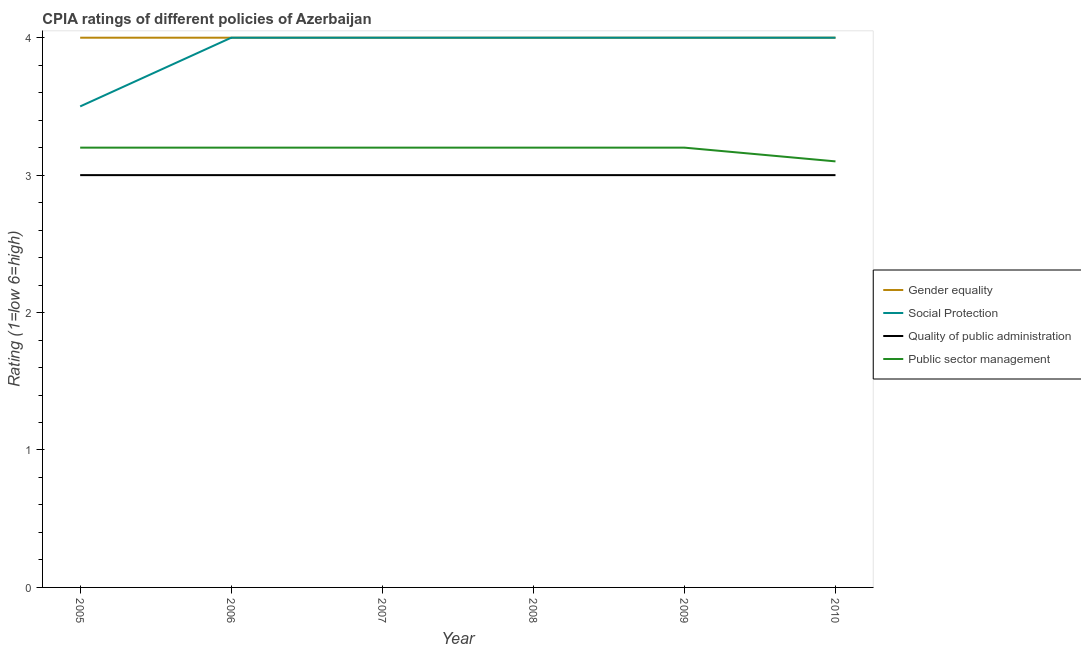How many different coloured lines are there?
Offer a terse response. 4. Does the line corresponding to cpia rating of quality of public administration intersect with the line corresponding to cpia rating of public sector management?
Your answer should be very brief. No. Is the number of lines equal to the number of legend labels?
Offer a terse response. Yes. What is the cpia rating of social protection in 2006?
Your answer should be very brief. 4. Across all years, what is the maximum cpia rating of quality of public administration?
Provide a short and direct response. 3. Across all years, what is the minimum cpia rating of gender equality?
Offer a terse response. 4. What is the difference between the cpia rating of social protection in 2007 and that in 2010?
Your answer should be very brief. 0. What is the difference between the cpia rating of quality of public administration in 2008 and the cpia rating of gender equality in 2010?
Offer a very short reply. -1. What is the average cpia rating of social protection per year?
Your response must be concise. 3.92. In the year 2010, what is the difference between the cpia rating of gender equality and cpia rating of quality of public administration?
Provide a succinct answer. 1. What is the ratio of the cpia rating of public sector management in 2006 to that in 2007?
Make the answer very short. 1. Is the cpia rating of gender equality in 2008 less than that in 2009?
Give a very brief answer. No. Is the difference between the cpia rating of public sector management in 2006 and 2010 greater than the difference between the cpia rating of social protection in 2006 and 2010?
Offer a very short reply. Yes. What is the difference between the highest and the second highest cpia rating of public sector management?
Your response must be concise. 0. Is the sum of the cpia rating of social protection in 2007 and 2008 greater than the maximum cpia rating of quality of public administration across all years?
Give a very brief answer. Yes. Does the cpia rating of quality of public administration monotonically increase over the years?
Offer a terse response. No. How many lines are there?
Keep it short and to the point. 4. How many years are there in the graph?
Provide a succinct answer. 6. What is the difference between two consecutive major ticks on the Y-axis?
Offer a terse response. 1. Does the graph contain grids?
Offer a terse response. No. Where does the legend appear in the graph?
Your response must be concise. Center right. How are the legend labels stacked?
Offer a terse response. Vertical. What is the title of the graph?
Your answer should be very brief. CPIA ratings of different policies of Azerbaijan. What is the Rating (1=low 6=high) in Gender equality in 2005?
Your response must be concise. 4. What is the Rating (1=low 6=high) of Quality of public administration in 2005?
Offer a very short reply. 3. What is the Rating (1=low 6=high) in Social Protection in 2006?
Give a very brief answer. 4. What is the Rating (1=low 6=high) of Gender equality in 2007?
Offer a terse response. 4. What is the Rating (1=low 6=high) of Gender equality in 2008?
Make the answer very short. 4. What is the Rating (1=low 6=high) in Social Protection in 2008?
Your answer should be compact. 4. What is the Rating (1=low 6=high) of Social Protection in 2009?
Offer a terse response. 4. What is the Rating (1=low 6=high) of Public sector management in 2009?
Provide a succinct answer. 3.2. What is the Rating (1=low 6=high) in Gender equality in 2010?
Your answer should be compact. 4. What is the Rating (1=low 6=high) of Public sector management in 2010?
Provide a short and direct response. 3.1. Across all years, what is the maximum Rating (1=low 6=high) in Social Protection?
Provide a short and direct response. 4. Across all years, what is the maximum Rating (1=low 6=high) in Public sector management?
Your response must be concise. 3.2. What is the total Rating (1=low 6=high) in Quality of public administration in the graph?
Your answer should be very brief. 18. What is the total Rating (1=low 6=high) in Public sector management in the graph?
Make the answer very short. 19.1. What is the difference between the Rating (1=low 6=high) in Public sector management in 2005 and that in 2006?
Your response must be concise. 0. What is the difference between the Rating (1=low 6=high) in Gender equality in 2005 and that in 2007?
Make the answer very short. 0. What is the difference between the Rating (1=low 6=high) of Social Protection in 2005 and that in 2007?
Offer a terse response. -0.5. What is the difference between the Rating (1=low 6=high) in Social Protection in 2005 and that in 2008?
Provide a short and direct response. -0.5. What is the difference between the Rating (1=low 6=high) in Public sector management in 2005 and that in 2008?
Your answer should be very brief. 0. What is the difference between the Rating (1=low 6=high) in Social Protection in 2005 and that in 2010?
Ensure brevity in your answer.  -0.5. What is the difference between the Rating (1=low 6=high) in Gender equality in 2006 and that in 2007?
Offer a very short reply. 0. What is the difference between the Rating (1=low 6=high) of Quality of public administration in 2006 and that in 2007?
Make the answer very short. 0. What is the difference between the Rating (1=low 6=high) of Public sector management in 2006 and that in 2007?
Provide a short and direct response. 0. What is the difference between the Rating (1=low 6=high) of Gender equality in 2006 and that in 2008?
Provide a succinct answer. 0. What is the difference between the Rating (1=low 6=high) in Public sector management in 2006 and that in 2008?
Your response must be concise. 0. What is the difference between the Rating (1=low 6=high) in Social Protection in 2006 and that in 2009?
Offer a terse response. 0. What is the difference between the Rating (1=low 6=high) of Quality of public administration in 2006 and that in 2009?
Your answer should be compact. 0. What is the difference between the Rating (1=low 6=high) of Public sector management in 2006 and that in 2009?
Provide a short and direct response. 0. What is the difference between the Rating (1=low 6=high) of Social Protection in 2006 and that in 2010?
Provide a succinct answer. 0. What is the difference between the Rating (1=low 6=high) in Quality of public administration in 2007 and that in 2008?
Keep it short and to the point. 0. What is the difference between the Rating (1=low 6=high) in Social Protection in 2007 and that in 2009?
Your answer should be compact. 0. What is the difference between the Rating (1=low 6=high) of Public sector management in 2007 and that in 2009?
Ensure brevity in your answer.  0. What is the difference between the Rating (1=low 6=high) of Social Protection in 2007 and that in 2010?
Ensure brevity in your answer.  0. What is the difference between the Rating (1=low 6=high) of Public sector management in 2008 and that in 2009?
Offer a terse response. 0. What is the difference between the Rating (1=low 6=high) of Social Protection in 2008 and that in 2010?
Provide a succinct answer. 0. What is the difference between the Rating (1=low 6=high) in Quality of public administration in 2008 and that in 2010?
Your response must be concise. 0. What is the difference between the Rating (1=low 6=high) of Public sector management in 2008 and that in 2010?
Provide a short and direct response. 0.1. What is the difference between the Rating (1=low 6=high) of Social Protection in 2009 and that in 2010?
Offer a terse response. 0. What is the difference between the Rating (1=low 6=high) in Quality of public administration in 2009 and that in 2010?
Offer a terse response. 0. What is the difference between the Rating (1=low 6=high) in Public sector management in 2009 and that in 2010?
Offer a very short reply. 0.1. What is the difference between the Rating (1=low 6=high) in Gender equality in 2005 and the Rating (1=low 6=high) in Social Protection in 2006?
Your answer should be compact. 0. What is the difference between the Rating (1=low 6=high) in Gender equality in 2005 and the Rating (1=low 6=high) in Public sector management in 2006?
Provide a succinct answer. 0.8. What is the difference between the Rating (1=low 6=high) in Quality of public administration in 2005 and the Rating (1=low 6=high) in Public sector management in 2006?
Provide a short and direct response. -0.2. What is the difference between the Rating (1=low 6=high) in Gender equality in 2005 and the Rating (1=low 6=high) in Quality of public administration in 2007?
Keep it short and to the point. 1. What is the difference between the Rating (1=low 6=high) of Social Protection in 2005 and the Rating (1=low 6=high) of Quality of public administration in 2007?
Provide a succinct answer. 0.5. What is the difference between the Rating (1=low 6=high) of Gender equality in 2005 and the Rating (1=low 6=high) of Public sector management in 2008?
Make the answer very short. 0.8. What is the difference between the Rating (1=low 6=high) in Social Protection in 2005 and the Rating (1=low 6=high) in Quality of public administration in 2008?
Ensure brevity in your answer.  0.5. What is the difference between the Rating (1=low 6=high) of Social Protection in 2005 and the Rating (1=low 6=high) of Public sector management in 2008?
Give a very brief answer. 0.3. What is the difference between the Rating (1=low 6=high) in Quality of public administration in 2005 and the Rating (1=low 6=high) in Public sector management in 2008?
Offer a very short reply. -0.2. What is the difference between the Rating (1=low 6=high) in Gender equality in 2005 and the Rating (1=low 6=high) in Social Protection in 2009?
Offer a terse response. 0. What is the difference between the Rating (1=low 6=high) in Gender equality in 2005 and the Rating (1=low 6=high) in Quality of public administration in 2009?
Your answer should be compact. 1. What is the difference between the Rating (1=low 6=high) in Social Protection in 2005 and the Rating (1=low 6=high) in Quality of public administration in 2009?
Provide a short and direct response. 0.5. What is the difference between the Rating (1=low 6=high) of Quality of public administration in 2005 and the Rating (1=low 6=high) of Public sector management in 2009?
Your answer should be very brief. -0.2. What is the difference between the Rating (1=low 6=high) in Social Protection in 2005 and the Rating (1=low 6=high) in Public sector management in 2010?
Your response must be concise. 0.4. What is the difference between the Rating (1=low 6=high) of Gender equality in 2006 and the Rating (1=low 6=high) of Quality of public administration in 2007?
Your answer should be compact. 1. What is the difference between the Rating (1=low 6=high) of Quality of public administration in 2006 and the Rating (1=low 6=high) of Public sector management in 2007?
Your answer should be very brief. -0.2. What is the difference between the Rating (1=low 6=high) in Gender equality in 2006 and the Rating (1=low 6=high) in Quality of public administration in 2008?
Make the answer very short. 1. What is the difference between the Rating (1=low 6=high) in Social Protection in 2006 and the Rating (1=low 6=high) in Quality of public administration in 2008?
Your answer should be compact. 1. What is the difference between the Rating (1=low 6=high) of Social Protection in 2006 and the Rating (1=low 6=high) of Public sector management in 2008?
Give a very brief answer. 0.8. What is the difference between the Rating (1=low 6=high) in Gender equality in 2006 and the Rating (1=low 6=high) in Social Protection in 2009?
Your answer should be compact. 0. What is the difference between the Rating (1=low 6=high) in Gender equality in 2006 and the Rating (1=low 6=high) in Quality of public administration in 2009?
Give a very brief answer. 1. What is the difference between the Rating (1=low 6=high) in Social Protection in 2006 and the Rating (1=low 6=high) in Quality of public administration in 2009?
Offer a very short reply. 1. What is the difference between the Rating (1=low 6=high) of Social Protection in 2006 and the Rating (1=low 6=high) of Public sector management in 2009?
Give a very brief answer. 0.8. What is the difference between the Rating (1=low 6=high) of Gender equality in 2006 and the Rating (1=low 6=high) of Social Protection in 2010?
Offer a very short reply. 0. What is the difference between the Rating (1=low 6=high) in Gender equality in 2006 and the Rating (1=low 6=high) in Quality of public administration in 2010?
Provide a short and direct response. 1. What is the difference between the Rating (1=low 6=high) of Gender equality in 2006 and the Rating (1=low 6=high) of Public sector management in 2010?
Provide a succinct answer. 0.9. What is the difference between the Rating (1=low 6=high) of Social Protection in 2006 and the Rating (1=low 6=high) of Quality of public administration in 2010?
Keep it short and to the point. 1. What is the difference between the Rating (1=low 6=high) of Gender equality in 2007 and the Rating (1=low 6=high) of Quality of public administration in 2008?
Keep it short and to the point. 1. What is the difference between the Rating (1=low 6=high) of Gender equality in 2007 and the Rating (1=low 6=high) of Public sector management in 2008?
Your answer should be very brief. 0.8. What is the difference between the Rating (1=low 6=high) of Social Protection in 2007 and the Rating (1=low 6=high) of Quality of public administration in 2008?
Offer a terse response. 1. What is the difference between the Rating (1=low 6=high) in Social Protection in 2007 and the Rating (1=low 6=high) in Public sector management in 2008?
Offer a terse response. 0.8. What is the difference between the Rating (1=low 6=high) in Gender equality in 2007 and the Rating (1=low 6=high) in Social Protection in 2009?
Offer a terse response. 0. What is the difference between the Rating (1=low 6=high) in Gender equality in 2007 and the Rating (1=low 6=high) in Public sector management in 2009?
Your response must be concise. 0.8. What is the difference between the Rating (1=low 6=high) of Social Protection in 2007 and the Rating (1=low 6=high) of Quality of public administration in 2009?
Your answer should be compact. 1. What is the difference between the Rating (1=low 6=high) of Quality of public administration in 2007 and the Rating (1=low 6=high) of Public sector management in 2009?
Your answer should be very brief. -0.2. What is the difference between the Rating (1=low 6=high) in Gender equality in 2007 and the Rating (1=low 6=high) in Social Protection in 2010?
Provide a succinct answer. 0. What is the difference between the Rating (1=low 6=high) in Social Protection in 2007 and the Rating (1=low 6=high) in Quality of public administration in 2010?
Make the answer very short. 1. What is the difference between the Rating (1=low 6=high) of Quality of public administration in 2007 and the Rating (1=low 6=high) of Public sector management in 2010?
Provide a succinct answer. -0.1. What is the difference between the Rating (1=low 6=high) in Gender equality in 2008 and the Rating (1=low 6=high) in Social Protection in 2009?
Provide a short and direct response. 0. What is the difference between the Rating (1=low 6=high) of Gender equality in 2008 and the Rating (1=low 6=high) of Quality of public administration in 2009?
Your response must be concise. 1. What is the difference between the Rating (1=low 6=high) of Gender equality in 2008 and the Rating (1=low 6=high) of Public sector management in 2009?
Your answer should be very brief. 0.8. What is the difference between the Rating (1=low 6=high) of Social Protection in 2008 and the Rating (1=low 6=high) of Quality of public administration in 2009?
Your answer should be very brief. 1. What is the difference between the Rating (1=low 6=high) of Social Protection in 2008 and the Rating (1=low 6=high) of Public sector management in 2009?
Your response must be concise. 0.8. What is the difference between the Rating (1=low 6=high) in Gender equality in 2008 and the Rating (1=low 6=high) in Quality of public administration in 2010?
Your answer should be compact. 1. What is the difference between the Rating (1=low 6=high) of Gender equality in 2008 and the Rating (1=low 6=high) of Public sector management in 2010?
Keep it short and to the point. 0.9. What is the difference between the Rating (1=low 6=high) in Quality of public administration in 2008 and the Rating (1=low 6=high) in Public sector management in 2010?
Keep it short and to the point. -0.1. What is the difference between the Rating (1=low 6=high) of Gender equality in 2009 and the Rating (1=low 6=high) of Quality of public administration in 2010?
Your answer should be compact. 1. What is the difference between the Rating (1=low 6=high) in Gender equality in 2009 and the Rating (1=low 6=high) in Public sector management in 2010?
Offer a terse response. 0.9. What is the average Rating (1=low 6=high) of Social Protection per year?
Ensure brevity in your answer.  3.92. What is the average Rating (1=low 6=high) of Quality of public administration per year?
Provide a succinct answer. 3. What is the average Rating (1=low 6=high) of Public sector management per year?
Offer a very short reply. 3.18. In the year 2005, what is the difference between the Rating (1=low 6=high) in Gender equality and Rating (1=low 6=high) in Social Protection?
Offer a very short reply. 0.5. In the year 2005, what is the difference between the Rating (1=low 6=high) in Gender equality and Rating (1=low 6=high) in Quality of public administration?
Ensure brevity in your answer.  1. In the year 2005, what is the difference between the Rating (1=low 6=high) in Social Protection and Rating (1=low 6=high) in Quality of public administration?
Make the answer very short. 0.5. In the year 2005, what is the difference between the Rating (1=low 6=high) of Social Protection and Rating (1=low 6=high) of Public sector management?
Give a very brief answer. 0.3. In the year 2006, what is the difference between the Rating (1=low 6=high) of Gender equality and Rating (1=low 6=high) of Social Protection?
Ensure brevity in your answer.  0. In the year 2006, what is the difference between the Rating (1=low 6=high) of Gender equality and Rating (1=low 6=high) of Quality of public administration?
Give a very brief answer. 1. In the year 2006, what is the difference between the Rating (1=low 6=high) of Social Protection and Rating (1=low 6=high) of Quality of public administration?
Offer a terse response. 1. In the year 2007, what is the difference between the Rating (1=low 6=high) in Gender equality and Rating (1=low 6=high) in Quality of public administration?
Offer a terse response. 1. In the year 2007, what is the difference between the Rating (1=low 6=high) of Gender equality and Rating (1=low 6=high) of Public sector management?
Your response must be concise. 0.8. In the year 2008, what is the difference between the Rating (1=low 6=high) in Gender equality and Rating (1=low 6=high) in Social Protection?
Offer a terse response. 0. In the year 2008, what is the difference between the Rating (1=low 6=high) of Quality of public administration and Rating (1=low 6=high) of Public sector management?
Keep it short and to the point. -0.2. In the year 2009, what is the difference between the Rating (1=low 6=high) of Gender equality and Rating (1=low 6=high) of Social Protection?
Your answer should be very brief. 0. In the year 2009, what is the difference between the Rating (1=low 6=high) of Gender equality and Rating (1=low 6=high) of Quality of public administration?
Provide a succinct answer. 1. In the year 2010, what is the difference between the Rating (1=low 6=high) of Social Protection and Rating (1=low 6=high) of Public sector management?
Provide a short and direct response. 0.9. In the year 2010, what is the difference between the Rating (1=low 6=high) of Quality of public administration and Rating (1=low 6=high) of Public sector management?
Provide a short and direct response. -0.1. What is the ratio of the Rating (1=low 6=high) in Gender equality in 2005 to that in 2006?
Keep it short and to the point. 1. What is the ratio of the Rating (1=low 6=high) in Gender equality in 2005 to that in 2007?
Make the answer very short. 1. What is the ratio of the Rating (1=low 6=high) of Public sector management in 2005 to that in 2007?
Offer a terse response. 1. What is the ratio of the Rating (1=low 6=high) in Quality of public administration in 2005 to that in 2008?
Your answer should be compact. 1. What is the ratio of the Rating (1=low 6=high) in Public sector management in 2005 to that in 2008?
Provide a short and direct response. 1. What is the ratio of the Rating (1=low 6=high) of Gender equality in 2005 to that in 2009?
Give a very brief answer. 1. What is the ratio of the Rating (1=low 6=high) of Social Protection in 2005 to that in 2009?
Make the answer very short. 0.88. What is the ratio of the Rating (1=low 6=high) in Public sector management in 2005 to that in 2010?
Provide a short and direct response. 1.03. What is the ratio of the Rating (1=low 6=high) of Gender equality in 2006 to that in 2007?
Make the answer very short. 1. What is the ratio of the Rating (1=low 6=high) in Quality of public administration in 2006 to that in 2007?
Your answer should be very brief. 1. What is the ratio of the Rating (1=low 6=high) of Social Protection in 2006 to that in 2008?
Your answer should be compact. 1. What is the ratio of the Rating (1=low 6=high) in Quality of public administration in 2006 to that in 2008?
Your answer should be compact. 1. What is the ratio of the Rating (1=low 6=high) of Social Protection in 2006 to that in 2009?
Give a very brief answer. 1. What is the ratio of the Rating (1=low 6=high) in Quality of public administration in 2006 to that in 2009?
Ensure brevity in your answer.  1. What is the ratio of the Rating (1=low 6=high) in Public sector management in 2006 to that in 2009?
Offer a terse response. 1. What is the ratio of the Rating (1=low 6=high) of Gender equality in 2006 to that in 2010?
Offer a terse response. 1. What is the ratio of the Rating (1=low 6=high) of Quality of public administration in 2006 to that in 2010?
Provide a short and direct response. 1. What is the ratio of the Rating (1=low 6=high) in Public sector management in 2006 to that in 2010?
Provide a succinct answer. 1.03. What is the ratio of the Rating (1=low 6=high) of Gender equality in 2007 to that in 2008?
Offer a very short reply. 1. What is the ratio of the Rating (1=low 6=high) of Social Protection in 2007 to that in 2008?
Ensure brevity in your answer.  1. What is the ratio of the Rating (1=low 6=high) in Quality of public administration in 2007 to that in 2008?
Provide a succinct answer. 1. What is the ratio of the Rating (1=low 6=high) of Public sector management in 2007 to that in 2009?
Offer a terse response. 1. What is the ratio of the Rating (1=low 6=high) in Social Protection in 2007 to that in 2010?
Your response must be concise. 1. What is the ratio of the Rating (1=low 6=high) of Public sector management in 2007 to that in 2010?
Make the answer very short. 1.03. What is the ratio of the Rating (1=low 6=high) in Quality of public administration in 2008 to that in 2009?
Make the answer very short. 1. What is the ratio of the Rating (1=low 6=high) in Social Protection in 2008 to that in 2010?
Offer a terse response. 1. What is the ratio of the Rating (1=low 6=high) of Public sector management in 2008 to that in 2010?
Provide a succinct answer. 1.03. What is the ratio of the Rating (1=low 6=high) in Gender equality in 2009 to that in 2010?
Make the answer very short. 1. What is the ratio of the Rating (1=low 6=high) of Social Protection in 2009 to that in 2010?
Make the answer very short. 1. What is the ratio of the Rating (1=low 6=high) of Public sector management in 2009 to that in 2010?
Offer a terse response. 1.03. What is the difference between the highest and the second highest Rating (1=low 6=high) of Social Protection?
Keep it short and to the point. 0. What is the difference between the highest and the second highest Rating (1=low 6=high) of Quality of public administration?
Make the answer very short. 0. What is the difference between the highest and the lowest Rating (1=low 6=high) of Public sector management?
Give a very brief answer. 0.1. 